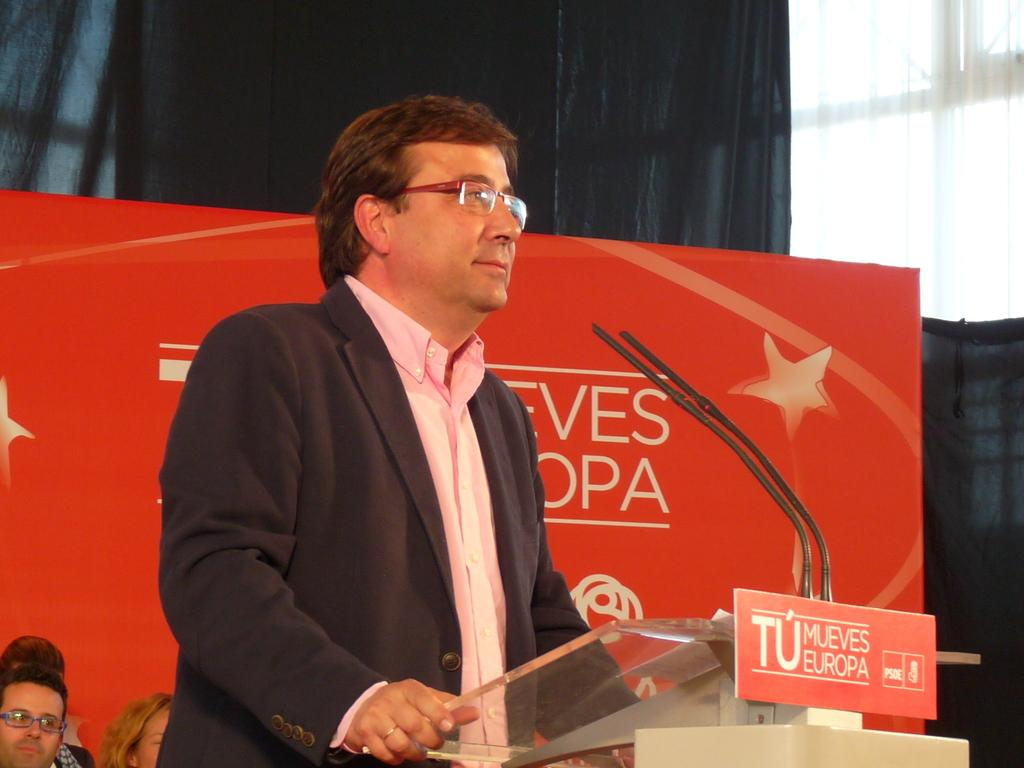What is the person in the image doing? There is a person standing at a desk in the image. What can be seen in the background of the image? There is a poster, a curtain, a wall, and a group of persons in the background of the image. What type of bottle is being used by the actor in the image? There is no actor or bottle present in the image. What is inside the jar that is visible in the image? There is no jar present in the image. 